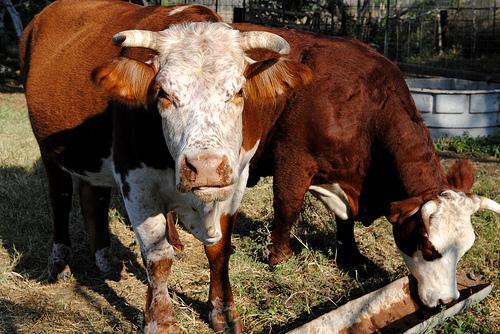How many cows are directly facing the camera?
Give a very brief answer. 1. 